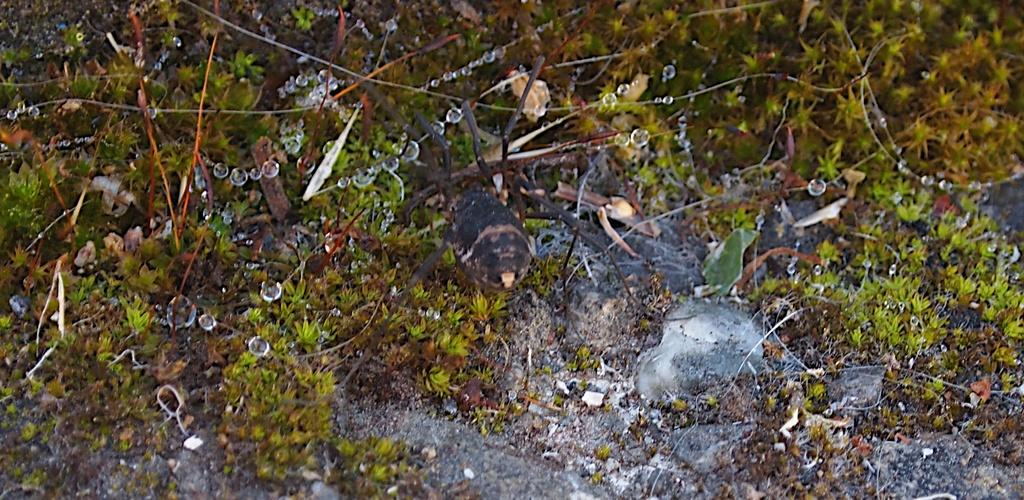What type of living organisms can be seen in the image? Plants can be seen in the image. What can be observed on the plants in the image? There are water droplets visible in the image. How many branches can be seen on the plants in the image? The provided facts do not mention any branches on the plants in the image. What are the cats' desires in the image? There are no cats present in the image, so their desires cannot be determined. 